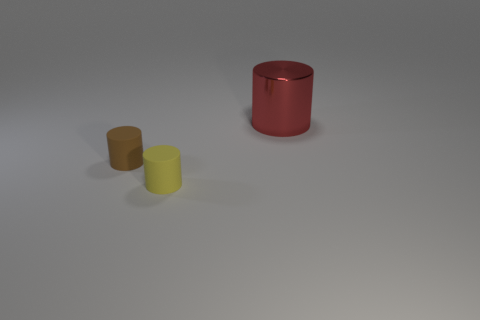What size is the red metallic cylinder?
Your answer should be compact. Large. Are there fewer big red metallic cylinders behind the tiny yellow matte cylinder than green shiny balls?
Your answer should be compact. No. Does the rubber thing in front of the tiny brown matte cylinder have the same color as the big metallic object?
Provide a succinct answer. No. How many matte things are either red cylinders or cylinders?
Offer a very short reply. 2. Is there anything else that is the same size as the red cylinder?
Offer a very short reply. No. What is the color of the other small cylinder that is the same material as the yellow cylinder?
Give a very brief answer. Brown. How many cylinders are gray metallic things or large metallic things?
Offer a very short reply. 1. How many things are either brown objects or tiny rubber objects that are in front of the tiny brown rubber cylinder?
Offer a very short reply. 2. Is there a big green rubber object?
Make the answer very short. No. There is a matte cylinder that is to the right of the rubber object left of the small yellow matte object; what is its size?
Make the answer very short. Small. 